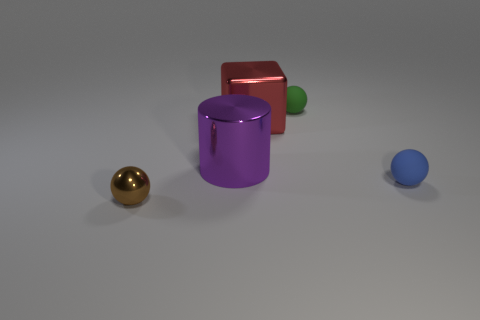What can you tell me about the colors in this scene? The scene features a vibrant array of colors. There's a shiny golden sphere, a purple cylinder with a reflective surface, and a matte red cube. The green and blue spheres have a less reflective, possibly rubbery surface. The colors contrast nicely with each other and stand out against the neutral background. 